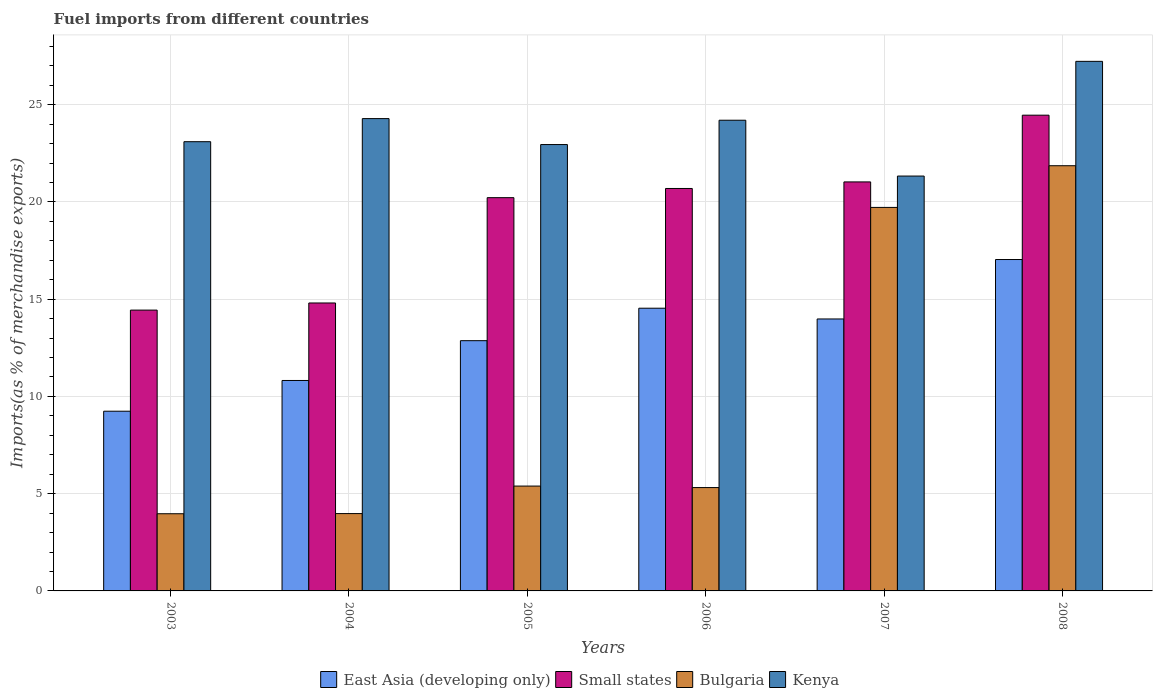How many groups of bars are there?
Your answer should be very brief. 6. What is the label of the 2nd group of bars from the left?
Make the answer very short. 2004. In how many cases, is the number of bars for a given year not equal to the number of legend labels?
Your answer should be very brief. 0. What is the percentage of imports to different countries in Bulgaria in 2006?
Ensure brevity in your answer.  5.31. Across all years, what is the maximum percentage of imports to different countries in East Asia (developing only)?
Offer a very short reply. 17.04. Across all years, what is the minimum percentage of imports to different countries in East Asia (developing only)?
Make the answer very short. 9.24. In which year was the percentage of imports to different countries in Small states maximum?
Your response must be concise. 2008. In which year was the percentage of imports to different countries in Bulgaria minimum?
Ensure brevity in your answer.  2003. What is the total percentage of imports to different countries in East Asia (developing only) in the graph?
Give a very brief answer. 78.48. What is the difference between the percentage of imports to different countries in Bulgaria in 2004 and that in 2008?
Provide a succinct answer. -17.88. What is the difference between the percentage of imports to different countries in Kenya in 2007 and the percentage of imports to different countries in Small states in 2006?
Provide a succinct answer. 0.64. What is the average percentage of imports to different countries in Kenya per year?
Your answer should be compact. 23.85. In the year 2005, what is the difference between the percentage of imports to different countries in Bulgaria and percentage of imports to different countries in Kenya?
Your response must be concise. -17.56. In how many years, is the percentage of imports to different countries in Kenya greater than 27 %?
Offer a terse response. 1. What is the ratio of the percentage of imports to different countries in Kenya in 2003 to that in 2004?
Offer a very short reply. 0.95. Is the percentage of imports to different countries in East Asia (developing only) in 2004 less than that in 2006?
Give a very brief answer. Yes. What is the difference between the highest and the second highest percentage of imports to different countries in East Asia (developing only)?
Make the answer very short. 2.5. What is the difference between the highest and the lowest percentage of imports to different countries in Kenya?
Offer a terse response. 5.9. Is the sum of the percentage of imports to different countries in East Asia (developing only) in 2006 and 2008 greater than the maximum percentage of imports to different countries in Bulgaria across all years?
Make the answer very short. Yes. What does the 4th bar from the left in 2006 represents?
Offer a very short reply. Kenya. What does the 3rd bar from the right in 2008 represents?
Offer a terse response. Small states. Is it the case that in every year, the sum of the percentage of imports to different countries in Small states and percentage of imports to different countries in East Asia (developing only) is greater than the percentage of imports to different countries in Bulgaria?
Keep it short and to the point. Yes. How many years are there in the graph?
Your response must be concise. 6. Does the graph contain any zero values?
Provide a short and direct response. No. Does the graph contain grids?
Offer a terse response. Yes. How many legend labels are there?
Offer a terse response. 4. What is the title of the graph?
Your answer should be very brief. Fuel imports from different countries. What is the label or title of the X-axis?
Give a very brief answer. Years. What is the label or title of the Y-axis?
Provide a short and direct response. Imports(as % of merchandise exports). What is the Imports(as % of merchandise exports) in East Asia (developing only) in 2003?
Offer a terse response. 9.24. What is the Imports(as % of merchandise exports) in Small states in 2003?
Ensure brevity in your answer.  14.44. What is the Imports(as % of merchandise exports) of Bulgaria in 2003?
Offer a terse response. 3.97. What is the Imports(as % of merchandise exports) of Kenya in 2003?
Your response must be concise. 23.1. What is the Imports(as % of merchandise exports) in East Asia (developing only) in 2004?
Keep it short and to the point. 10.82. What is the Imports(as % of merchandise exports) of Small states in 2004?
Offer a very short reply. 14.8. What is the Imports(as % of merchandise exports) of Bulgaria in 2004?
Make the answer very short. 3.98. What is the Imports(as % of merchandise exports) in Kenya in 2004?
Your answer should be compact. 24.28. What is the Imports(as % of merchandise exports) of East Asia (developing only) in 2005?
Provide a short and direct response. 12.87. What is the Imports(as % of merchandise exports) of Small states in 2005?
Your answer should be compact. 20.22. What is the Imports(as % of merchandise exports) of Bulgaria in 2005?
Make the answer very short. 5.39. What is the Imports(as % of merchandise exports) of Kenya in 2005?
Provide a succinct answer. 22.95. What is the Imports(as % of merchandise exports) in East Asia (developing only) in 2006?
Make the answer very short. 14.54. What is the Imports(as % of merchandise exports) in Small states in 2006?
Ensure brevity in your answer.  20.69. What is the Imports(as % of merchandise exports) in Bulgaria in 2006?
Make the answer very short. 5.31. What is the Imports(as % of merchandise exports) in Kenya in 2006?
Your answer should be compact. 24.2. What is the Imports(as % of merchandise exports) in East Asia (developing only) in 2007?
Offer a very short reply. 13.98. What is the Imports(as % of merchandise exports) in Small states in 2007?
Ensure brevity in your answer.  21.03. What is the Imports(as % of merchandise exports) of Bulgaria in 2007?
Your answer should be compact. 19.72. What is the Imports(as % of merchandise exports) in Kenya in 2007?
Provide a succinct answer. 21.33. What is the Imports(as % of merchandise exports) in East Asia (developing only) in 2008?
Offer a very short reply. 17.04. What is the Imports(as % of merchandise exports) of Small states in 2008?
Your answer should be compact. 24.46. What is the Imports(as % of merchandise exports) in Bulgaria in 2008?
Ensure brevity in your answer.  21.86. What is the Imports(as % of merchandise exports) of Kenya in 2008?
Offer a very short reply. 27.23. Across all years, what is the maximum Imports(as % of merchandise exports) of East Asia (developing only)?
Your answer should be very brief. 17.04. Across all years, what is the maximum Imports(as % of merchandise exports) of Small states?
Offer a very short reply. 24.46. Across all years, what is the maximum Imports(as % of merchandise exports) in Bulgaria?
Provide a short and direct response. 21.86. Across all years, what is the maximum Imports(as % of merchandise exports) of Kenya?
Offer a very short reply. 27.23. Across all years, what is the minimum Imports(as % of merchandise exports) in East Asia (developing only)?
Offer a very short reply. 9.24. Across all years, what is the minimum Imports(as % of merchandise exports) of Small states?
Keep it short and to the point. 14.44. Across all years, what is the minimum Imports(as % of merchandise exports) of Bulgaria?
Offer a very short reply. 3.97. Across all years, what is the minimum Imports(as % of merchandise exports) of Kenya?
Give a very brief answer. 21.33. What is the total Imports(as % of merchandise exports) in East Asia (developing only) in the graph?
Ensure brevity in your answer.  78.48. What is the total Imports(as % of merchandise exports) of Small states in the graph?
Provide a succinct answer. 115.64. What is the total Imports(as % of merchandise exports) of Bulgaria in the graph?
Give a very brief answer. 60.23. What is the total Imports(as % of merchandise exports) in Kenya in the graph?
Your answer should be very brief. 143.08. What is the difference between the Imports(as % of merchandise exports) in East Asia (developing only) in 2003 and that in 2004?
Keep it short and to the point. -1.58. What is the difference between the Imports(as % of merchandise exports) of Small states in 2003 and that in 2004?
Your answer should be compact. -0.37. What is the difference between the Imports(as % of merchandise exports) of Bulgaria in 2003 and that in 2004?
Keep it short and to the point. -0.01. What is the difference between the Imports(as % of merchandise exports) in Kenya in 2003 and that in 2004?
Provide a short and direct response. -1.19. What is the difference between the Imports(as % of merchandise exports) of East Asia (developing only) in 2003 and that in 2005?
Give a very brief answer. -3.63. What is the difference between the Imports(as % of merchandise exports) in Small states in 2003 and that in 2005?
Ensure brevity in your answer.  -5.78. What is the difference between the Imports(as % of merchandise exports) in Bulgaria in 2003 and that in 2005?
Give a very brief answer. -1.42. What is the difference between the Imports(as % of merchandise exports) in Kenya in 2003 and that in 2005?
Your answer should be compact. 0.15. What is the difference between the Imports(as % of merchandise exports) of East Asia (developing only) in 2003 and that in 2006?
Provide a short and direct response. -5.3. What is the difference between the Imports(as % of merchandise exports) of Small states in 2003 and that in 2006?
Make the answer very short. -6.25. What is the difference between the Imports(as % of merchandise exports) in Bulgaria in 2003 and that in 2006?
Your response must be concise. -1.35. What is the difference between the Imports(as % of merchandise exports) of Kenya in 2003 and that in 2006?
Your response must be concise. -1.1. What is the difference between the Imports(as % of merchandise exports) of East Asia (developing only) in 2003 and that in 2007?
Your answer should be compact. -4.74. What is the difference between the Imports(as % of merchandise exports) of Small states in 2003 and that in 2007?
Provide a succinct answer. -6.59. What is the difference between the Imports(as % of merchandise exports) in Bulgaria in 2003 and that in 2007?
Provide a succinct answer. -15.75. What is the difference between the Imports(as % of merchandise exports) in Kenya in 2003 and that in 2007?
Your answer should be compact. 1.77. What is the difference between the Imports(as % of merchandise exports) in East Asia (developing only) in 2003 and that in 2008?
Give a very brief answer. -7.8. What is the difference between the Imports(as % of merchandise exports) of Small states in 2003 and that in 2008?
Give a very brief answer. -10.02. What is the difference between the Imports(as % of merchandise exports) of Bulgaria in 2003 and that in 2008?
Provide a succinct answer. -17.89. What is the difference between the Imports(as % of merchandise exports) in Kenya in 2003 and that in 2008?
Provide a succinct answer. -4.13. What is the difference between the Imports(as % of merchandise exports) of East Asia (developing only) in 2004 and that in 2005?
Give a very brief answer. -2.05. What is the difference between the Imports(as % of merchandise exports) of Small states in 2004 and that in 2005?
Keep it short and to the point. -5.41. What is the difference between the Imports(as % of merchandise exports) in Bulgaria in 2004 and that in 2005?
Keep it short and to the point. -1.42. What is the difference between the Imports(as % of merchandise exports) in Kenya in 2004 and that in 2005?
Your answer should be compact. 1.33. What is the difference between the Imports(as % of merchandise exports) of East Asia (developing only) in 2004 and that in 2006?
Keep it short and to the point. -3.72. What is the difference between the Imports(as % of merchandise exports) of Small states in 2004 and that in 2006?
Make the answer very short. -5.89. What is the difference between the Imports(as % of merchandise exports) in Bulgaria in 2004 and that in 2006?
Ensure brevity in your answer.  -1.34. What is the difference between the Imports(as % of merchandise exports) of Kenya in 2004 and that in 2006?
Your answer should be compact. 0.08. What is the difference between the Imports(as % of merchandise exports) of East Asia (developing only) in 2004 and that in 2007?
Ensure brevity in your answer.  -3.16. What is the difference between the Imports(as % of merchandise exports) of Small states in 2004 and that in 2007?
Offer a terse response. -6.22. What is the difference between the Imports(as % of merchandise exports) in Bulgaria in 2004 and that in 2007?
Your response must be concise. -15.74. What is the difference between the Imports(as % of merchandise exports) in Kenya in 2004 and that in 2007?
Provide a short and direct response. 2.95. What is the difference between the Imports(as % of merchandise exports) of East Asia (developing only) in 2004 and that in 2008?
Offer a terse response. -6.22. What is the difference between the Imports(as % of merchandise exports) of Small states in 2004 and that in 2008?
Your response must be concise. -9.65. What is the difference between the Imports(as % of merchandise exports) of Bulgaria in 2004 and that in 2008?
Give a very brief answer. -17.88. What is the difference between the Imports(as % of merchandise exports) in Kenya in 2004 and that in 2008?
Your answer should be very brief. -2.94. What is the difference between the Imports(as % of merchandise exports) in East Asia (developing only) in 2005 and that in 2006?
Your answer should be compact. -1.67. What is the difference between the Imports(as % of merchandise exports) of Small states in 2005 and that in 2006?
Offer a terse response. -0.47. What is the difference between the Imports(as % of merchandise exports) in Bulgaria in 2005 and that in 2006?
Your answer should be very brief. 0.08. What is the difference between the Imports(as % of merchandise exports) in Kenya in 2005 and that in 2006?
Provide a succinct answer. -1.25. What is the difference between the Imports(as % of merchandise exports) in East Asia (developing only) in 2005 and that in 2007?
Provide a succinct answer. -1.12. What is the difference between the Imports(as % of merchandise exports) of Small states in 2005 and that in 2007?
Make the answer very short. -0.81. What is the difference between the Imports(as % of merchandise exports) of Bulgaria in 2005 and that in 2007?
Provide a short and direct response. -14.33. What is the difference between the Imports(as % of merchandise exports) of Kenya in 2005 and that in 2007?
Offer a terse response. 1.62. What is the difference between the Imports(as % of merchandise exports) of East Asia (developing only) in 2005 and that in 2008?
Offer a very short reply. -4.17. What is the difference between the Imports(as % of merchandise exports) of Small states in 2005 and that in 2008?
Offer a very short reply. -4.24. What is the difference between the Imports(as % of merchandise exports) in Bulgaria in 2005 and that in 2008?
Offer a very short reply. -16.47. What is the difference between the Imports(as % of merchandise exports) in Kenya in 2005 and that in 2008?
Give a very brief answer. -4.28. What is the difference between the Imports(as % of merchandise exports) in East Asia (developing only) in 2006 and that in 2007?
Ensure brevity in your answer.  0.55. What is the difference between the Imports(as % of merchandise exports) in Small states in 2006 and that in 2007?
Your response must be concise. -0.34. What is the difference between the Imports(as % of merchandise exports) of Bulgaria in 2006 and that in 2007?
Offer a very short reply. -14.4. What is the difference between the Imports(as % of merchandise exports) in Kenya in 2006 and that in 2007?
Offer a terse response. 2.87. What is the difference between the Imports(as % of merchandise exports) in East Asia (developing only) in 2006 and that in 2008?
Your answer should be compact. -2.5. What is the difference between the Imports(as % of merchandise exports) in Small states in 2006 and that in 2008?
Your response must be concise. -3.77. What is the difference between the Imports(as % of merchandise exports) of Bulgaria in 2006 and that in 2008?
Your answer should be compact. -16.55. What is the difference between the Imports(as % of merchandise exports) in Kenya in 2006 and that in 2008?
Make the answer very short. -3.03. What is the difference between the Imports(as % of merchandise exports) in East Asia (developing only) in 2007 and that in 2008?
Give a very brief answer. -3.06. What is the difference between the Imports(as % of merchandise exports) in Small states in 2007 and that in 2008?
Your answer should be compact. -3.43. What is the difference between the Imports(as % of merchandise exports) in Bulgaria in 2007 and that in 2008?
Keep it short and to the point. -2.14. What is the difference between the Imports(as % of merchandise exports) of Kenya in 2007 and that in 2008?
Keep it short and to the point. -5.9. What is the difference between the Imports(as % of merchandise exports) in East Asia (developing only) in 2003 and the Imports(as % of merchandise exports) in Small states in 2004?
Your answer should be very brief. -5.56. What is the difference between the Imports(as % of merchandise exports) in East Asia (developing only) in 2003 and the Imports(as % of merchandise exports) in Bulgaria in 2004?
Provide a short and direct response. 5.26. What is the difference between the Imports(as % of merchandise exports) of East Asia (developing only) in 2003 and the Imports(as % of merchandise exports) of Kenya in 2004?
Your answer should be compact. -15.04. What is the difference between the Imports(as % of merchandise exports) in Small states in 2003 and the Imports(as % of merchandise exports) in Bulgaria in 2004?
Provide a succinct answer. 10.46. What is the difference between the Imports(as % of merchandise exports) of Small states in 2003 and the Imports(as % of merchandise exports) of Kenya in 2004?
Give a very brief answer. -9.85. What is the difference between the Imports(as % of merchandise exports) in Bulgaria in 2003 and the Imports(as % of merchandise exports) in Kenya in 2004?
Your answer should be very brief. -20.32. What is the difference between the Imports(as % of merchandise exports) of East Asia (developing only) in 2003 and the Imports(as % of merchandise exports) of Small states in 2005?
Keep it short and to the point. -10.98. What is the difference between the Imports(as % of merchandise exports) in East Asia (developing only) in 2003 and the Imports(as % of merchandise exports) in Bulgaria in 2005?
Keep it short and to the point. 3.85. What is the difference between the Imports(as % of merchandise exports) in East Asia (developing only) in 2003 and the Imports(as % of merchandise exports) in Kenya in 2005?
Make the answer very short. -13.71. What is the difference between the Imports(as % of merchandise exports) in Small states in 2003 and the Imports(as % of merchandise exports) in Bulgaria in 2005?
Your answer should be very brief. 9.05. What is the difference between the Imports(as % of merchandise exports) of Small states in 2003 and the Imports(as % of merchandise exports) of Kenya in 2005?
Your response must be concise. -8.51. What is the difference between the Imports(as % of merchandise exports) of Bulgaria in 2003 and the Imports(as % of merchandise exports) of Kenya in 2005?
Offer a terse response. -18.98. What is the difference between the Imports(as % of merchandise exports) of East Asia (developing only) in 2003 and the Imports(as % of merchandise exports) of Small states in 2006?
Give a very brief answer. -11.45. What is the difference between the Imports(as % of merchandise exports) of East Asia (developing only) in 2003 and the Imports(as % of merchandise exports) of Bulgaria in 2006?
Keep it short and to the point. 3.93. What is the difference between the Imports(as % of merchandise exports) in East Asia (developing only) in 2003 and the Imports(as % of merchandise exports) in Kenya in 2006?
Make the answer very short. -14.96. What is the difference between the Imports(as % of merchandise exports) of Small states in 2003 and the Imports(as % of merchandise exports) of Bulgaria in 2006?
Make the answer very short. 9.12. What is the difference between the Imports(as % of merchandise exports) of Small states in 2003 and the Imports(as % of merchandise exports) of Kenya in 2006?
Your answer should be compact. -9.76. What is the difference between the Imports(as % of merchandise exports) in Bulgaria in 2003 and the Imports(as % of merchandise exports) in Kenya in 2006?
Your answer should be very brief. -20.23. What is the difference between the Imports(as % of merchandise exports) in East Asia (developing only) in 2003 and the Imports(as % of merchandise exports) in Small states in 2007?
Give a very brief answer. -11.79. What is the difference between the Imports(as % of merchandise exports) in East Asia (developing only) in 2003 and the Imports(as % of merchandise exports) in Bulgaria in 2007?
Make the answer very short. -10.48. What is the difference between the Imports(as % of merchandise exports) in East Asia (developing only) in 2003 and the Imports(as % of merchandise exports) in Kenya in 2007?
Provide a succinct answer. -12.09. What is the difference between the Imports(as % of merchandise exports) of Small states in 2003 and the Imports(as % of merchandise exports) of Bulgaria in 2007?
Keep it short and to the point. -5.28. What is the difference between the Imports(as % of merchandise exports) in Small states in 2003 and the Imports(as % of merchandise exports) in Kenya in 2007?
Your answer should be compact. -6.89. What is the difference between the Imports(as % of merchandise exports) in Bulgaria in 2003 and the Imports(as % of merchandise exports) in Kenya in 2007?
Your response must be concise. -17.36. What is the difference between the Imports(as % of merchandise exports) of East Asia (developing only) in 2003 and the Imports(as % of merchandise exports) of Small states in 2008?
Your answer should be compact. -15.22. What is the difference between the Imports(as % of merchandise exports) of East Asia (developing only) in 2003 and the Imports(as % of merchandise exports) of Bulgaria in 2008?
Ensure brevity in your answer.  -12.62. What is the difference between the Imports(as % of merchandise exports) in East Asia (developing only) in 2003 and the Imports(as % of merchandise exports) in Kenya in 2008?
Keep it short and to the point. -17.99. What is the difference between the Imports(as % of merchandise exports) of Small states in 2003 and the Imports(as % of merchandise exports) of Bulgaria in 2008?
Offer a very short reply. -7.42. What is the difference between the Imports(as % of merchandise exports) in Small states in 2003 and the Imports(as % of merchandise exports) in Kenya in 2008?
Offer a very short reply. -12.79. What is the difference between the Imports(as % of merchandise exports) in Bulgaria in 2003 and the Imports(as % of merchandise exports) in Kenya in 2008?
Provide a succinct answer. -23.26. What is the difference between the Imports(as % of merchandise exports) in East Asia (developing only) in 2004 and the Imports(as % of merchandise exports) in Small states in 2005?
Give a very brief answer. -9.4. What is the difference between the Imports(as % of merchandise exports) of East Asia (developing only) in 2004 and the Imports(as % of merchandise exports) of Bulgaria in 2005?
Keep it short and to the point. 5.43. What is the difference between the Imports(as % of merchandise exports) of East Asia (developing only) in 2004 and the Imports(as % of merchandise exports) of Kenya in 2005?
Offer a very short reply. -12.13. What is the difference between the Imports(as % of merchandise exports) of Small states in 2004 and the Imports(as % of merchandise exports) of Bulgaria in 2005?
Make the answer very short. 9.41. What is the difference between the Imports(as % of merchandise exports) in Small states in 2004 and the Imports(as % of merchandise exports) in Kenya in 2005?
Offer a terse response. -8.14. What is the difference between the Imports(as % of merchandise exports) of Bulgaria in 2004 and the Imports(as % of merchandise exports) of Kenya in 2005?
Provide a succinct answer. -18.97. What is the difference between the Imports(as % of merchandise exports) in East Asia (developing only) in 2004 and the Imports(as % of merchandise exports) in Small states in 2006?
Give a very brief answer. -9.87. What is the difference between the Imports(as % of merchandise exports) in East Asia (developing only) in 2004 and the Imports(as % of merchandise exports) in Bulgaria in 2006?
Ensure brevity in your answer.  5.51. What is the difference between the Imports(as % of merchandise exports) in East Asia (developing only) in 2004 and the Imports(as % of merchandise exports) in Kenya in 2006?
Your answer should be compact. -13.38. What is the difference between the Imports(as % of merchandise exports) of Small states in 2004 and the Imports(as % of merchandise exports) of Bulgaria in 2006?
Keep it short and to the point. 9.49. What is the difference between the Imports(as % of merchandise exports) in Small states in 2004 and the Imports(as % of merchandise exports) in Kenya in 2006?
Give a very brief answer. -9.4. What is the difference between the Imports(as % of merchandise exports) of Bulgaria in 2004 and the Imports(as % of merchandise exports) of Kenya in 2006?
Provide a succinct answer. -20.22. What is the difference between the Imports(as % of merchandise exports) of East Asia (developing only) in 2004 and the Imports(as % of merchandise exports) of Small states in 2007?
Provide a succinct answer. -10.21. What is the difference between the Imports(as % of merchandise exports) in East Asia (developing only) in 2004 and the Imports(as % of merchandise exports) in Bulgaria in 2007?
Your answer should be compact. -8.9. What is the difference between the Imports(as % of merchandise exports) of East Asia (developing only) in 2004 and the Imports(as % of merchandise exports) of Kenya in 2007?
Keep it short and to the point. -10.51. What is the difference between the Imports(as % of merchandise exports) of Small states in 2004 and the Imports(as % of merchandise exports) of Bulgaria in 2007?
Your answer should be very brief. -4.91. What is the difference between the Imports(as % of merchandise exports) in Small states in 2004 and the Imports(as % of merchandise exports) in Kenya in 2007?
Your answer should be compact. -6.53. What is the difference between the Imports(as % of merchandise exports) of Bulgaria in 2004 and the Imports(as % of merchandise exports) of Kenya in 2007?
Ensure brevity in your answer.  -17.35. What is the difference between the Imports(as % of merchandise exports) in East Asia (developing only) in 2004 and the Imports(as % of merchandise exports) in Small states in 2008?
Your answer should be very brief. -13.64. What is the difference between the Imports(as % of merchandise exports) in East Asia (developing only) in 2004 and the Imports(as % of merchandise exports) in Bulgaria in 2008?
Provide a succinct answer. -11.04. What is the difference between the Imports(as % of merchandise exports) in East Asia (developing only) in 2004 and the Imports(as % of merchandise exports) in Kenya in 2008?
Provide a succinct answer. -16.41. What is the difference between the Imports(as % of merchandise exports) in Small states in 2004 and the Imports(as % of merchandise exports) in Bulgaria in 2008?
Your answer should be very brief. -7.06. What is the difference between the Imports(as % of merchandise exports) in Small states in 2004 and the Imports(as % of merchandise exports) in Kenya in 2008?
Your answer should be very brief. -12.42. What is the difference between the Imports(as % of merchandise exports) of Bulgaria in 2004 and the Imports(as % of merchandise exports) of Kenya in 2008?
Give a very brief answer. -23.25. What is the difference between the Imports(as % of merchandise exports) in East Asia (developing only) in 2005 and the Imports(as % of merchandise exports) in Small states in 2006?
Ensure brevity in your answer.  -7.82. What is the difference between the Imports(as % of merchandise exports) in East Asia (developing only) in 2005 and the Imports(as % of merchandise exports) in Bulgaria in 2006?
Provide a short and direct response. 7.55. What is the difference between the Imports(as % of merchandise exports) in East Asia (developing only) in 2005 and the Imports(as % of merchandise exports) in Kenya in 2006?
Offer a very short reply. -11.33. What is the difference between the Imports(as % of merchandise exports) in Small states in 2005 and the Imports(as % of merchandise exports) in Bulgaria in 2006?
Give a very brief answer. 14.91. What is the difference between the Imports(as % of merchandise exports) of Small states in 2005 and the Imports(as % of merchandise exports) of Kenya in 2006?
Provide a short and direct response. -3.98. What is the difference between the Imports(as % of merchandise exports) of Bulgaria in 2005 and the Imports(as % of merchandise exports) of Kenya in 2006?
Give a very brief answer. -18.81. What is the difference between the Imports(as % of merchandise exports) of East Asia (developing only) in 2005 and the Imports(as % of merchandise exports) of Small states in 2007?
Provide a short and direct response. -8.16. What is the difference between the Imports(as % of merchandise exports) of East Asia (developing only) in 2005 and the Imports(as % of merchandise exports) of Bulgaria in 2007?
Offer a terse response. -6.85. What is the difference between the Imports(as % of merchandise exports) of East Asia (developing only) in 2005 and the Imports(as % of merchandise exports) of Kenya in 2007?
Provide a short and direct response. -8.46. What is the difference between the Imports(as % of merchandise exports) of Small states in 2005 and the Imports(as % of merchandise exports) of Bulgaria in 2007?
Offer a very short reply. 0.5. What is the difference between the Imports(as % of merchandise exports) of Small states in 2005 and the Imports(as % of merchandise exports) of Kenya in 2007?
Make the answer very short. -1.11. What is the difference between the Imports(as % of merchandise exports) in Bulgaria in 2005 and the Imports(as % of merchandise exports) in Kenya in 2007?
Offer a terse response. -15.94. What is the difference between the Imports(as % of merchandise exports) of East Asia (developing only) in 2005 and the Imports(as % of merchandise exports) of Small states in 2008?
Your answer should be very brief. -11.59. What is the difference between the Imports(as % of merchandise exports) of East Asia (developing only) in 2005 and the Imports(as % of merchandise exports) of Bulgaria in 2008?
Your answer should be very brief. -8.99. What is the difference between the Imports(as % of merchandise exports) of East Asia (developing only) in 2005 and the Imports(as % of merchandise exports) of Kenya in 2008?
Your answer should be very brief. -14.36. What is the difference between the Imports(as % of merchandise exports) in Small states in 2005 and the Imports(as % of merchandise exports) in Bulgaria in 2008?
Ensure brevity in your answer.  -1.64. What is the difference between the Imports(as % of merchandise exports) of Small states in 2005 and the Imports(as % of merchandise exports) of Kenya in 2008?
Provide a succinct answer. -7.01. What is the difference between the Imports(as % of merchandise exports) of Bulgaria in 2005 and the Imports(as % of merchandise exports) of Kenya in 2008?
Provide a short and direct response. -21.84. What is the difference between the Imports(as % of merchandise exports) of East Asia (developing only) in 2006 and the Imports(as % of merchandise exports) of Small states in 2007?
Your response must be concise. -6.49. What is the difference between the Imports(as % of merchandise exports) of East Asia (developing only) in 2006 and the Imports(as % of merchandise exports) of Bulgaria in 2007?
Ensure brevity in your answer.  -5.18. What is the difference between the Imports(as % of merchandise exports) of East Asia (developing only) in 2006 and the Imports(as % of merchandise exports) of Kenya in 2007?
Offer a terse response. -6.79. What is the difference between the Imports(as % of merchandise exports) in Small states in 2006 and the Imports(as % of merchandise exports) in Bulgaria in 2007?
Offer a very short reply. 0.97. What is the difference between the Imports(as % of merchandise exports) in Small states in 2006 and the Imports(as % of merchandise exports) in Kenya in 2007?
Provide a short and direct response. -0.64. What is the difference between the Imports(as % of merchandise exports) of Bulgaria in 2006 and the Imports(as % of merchandise exports) of Kenya in 2007?
Give a very brief answer. -16.02. What is the difference between the Imports(as % of merchandise exports) in East Asia (developing only) in 2006 and the Imports(as % of merchandise exports) in Small states in 2008?
Offer a terse response. -9.92. What is the difference between the Imports(as % of merchandise exports) of East Asia (developing only) in 2006 and the Imports(as % of merchandise exports) of Bulgaria in 2008?
Your answer should be compact. -7.33. What is the difference between the Imports(as % of merchandise exports) in East Asia (developing only) in 2006 and the Imports(as % of merchandise exports) in Kenya in 2008?
Ensure brevity in your answer.  -12.69. What is the difference between the Imports(as % of merchandise exports) in Small states in 2006 and the Imports(as % of merchandise exports) in Bulgaria in 2008?
Make the answer very short. -1.17. What is the difference between the Imports(as % of merchandise exports) in Small states in 2006 and the Imports(as % of merchandise exports) in Kenya in 2008?
Your answer should be compact. -6.54. What is the difference between the Imports(as % of merchandise exports) in Bulgaria in 2006 and the Imports(as % of merchandise exports) in Kenya in 2008?
Give a very brief answer. -21.91. What is the difference between the Imports(as % of merchandise exports) in East Asia (developing only) in 2007 and the Imports(as % of merchandise exports) in Small states in 2008?
Your answer should be compact. -10.48. What is the difference between the Imports(as % of merchandise exports) of East Asia (developing only) in 2007 and the Imports(as % of merchandise exports) of Bulgaria in 2008?
Provide a succinct answer. -7.88. What is the difference between the Imports(as % of merchandise exports) in East Asia (developing only) in 2007 and the Imports(as % of merchandise exports) in Kenya in 2008?
Your response must be concise. -13.24. What is the difference between the Imports(as % of merchandise exports) in Small states in 2007 and the Imports(as % of merchandise exports) in Bulgaria in 2008?
Keep it short and to the point. -0.83. What is the difference between the Imports(as % of merchandise exports) in Small states in 2007 and the Imports(as % of merchandise exports) in Kenya in 2008?
Provide a succinct answer. -6.2. What is the difference between the Imports(as % of merchandise exports) in Bulgaria in 2007 and the Imports(as % of merchandise exports) in Kenya in 2008?
Your response must be concise. -7.51. What is the average Imports(as % of merchandise exports) in East Asia (developing only) per year?
Provide a succinct answer. 13.08. What is the average Imports(as % of merchandise exports) in Small states per year?
Give a very brief answer. 19.27. What is the average Imports(as % of merchandise exports) of Bulgaria per year?
Keep it short and to the point. 10.04. What is the average Imports(as % of merchandise exports) in Kenya per year?
Offer a terse response. 23.85. In the year 2003, what is the difference between the Imports(as % of merchandise exports) in East Asia (developing only) and Imports(as % of merchandise exports) in Small states?
Provide a succinct answer. -5.2. In the year 2003, what is the difference between the Imports(as % of merchandise exports) of East Asia (developing only) and Imports(as % of merchandise exports) of Bulgaria?
Your response must be concise. 5.27. In the year 2003, what is the difference between the Imports(as % of merchandise exports) of East Asia (developing only) and Imports(as % of merchandise exports) of Kenya?
Offer a very short reply. -13.86. In the year 2003, what is the difference between the Imports(as % of merchandise exports) of Small states and Imports(as % of merchandise exports) of Bulgaria?
Provide a succinct answer. 10.47. In the year 2003, what is the difference between the Imports(as % of merchandise exports) in Small states and Imports(as % of merchandise exports) in Kenya?
Offer a very short reply. -8.66. In the year 2003, what is the difference between the Imports(as % of merchandise exports) in Bulgaria and Imports(as % of merchandise exports) in Kenya?
Ensure brevity in your answer.  -19.13. In the year 2004, what is the difference between the Imports(as % of merchandise exports) in East Asia (developing only) and Imports(as % of merchandise exports) in Small states?
Your answer should be very brief. -3.98. In the year 2004, what is the difference between the Imports(as % of merchandise exports) of East Asia (developing only) and Imports(as % of merchandise exports) of Bulgaria?
Keep it short and to the point. 6.84. In the year 2004, what is the difference between the Imports(as % of merchandise exports) of East Asia (developing only) and Imports(as % of merchandise exports) of Kenya?
Your answer should be very brief. -13.46. In the year 2004, what is the difference between the Imports(as % of merchandise exports) of Small states and Imports(as % of merchandise exports) of Bulgaria?
Give a very brief answer. 10.83. In the year 2004, what is the difference between the Imports(as % of merchandise exports) in Small states and Imports(as % of merchandise exports) in Kenya?
Your response must be concise. -9.48. In the year 2004, what is the difference between the Imports(as % of merchandise exports) of Bulgaria and Imports(as % of merchandise exports) of Kenya?
Offer a terse response. -20.31. In the year 2005, what is the difference between the Imports(as % of merchandise exports) of East Asia (developing only) and Imports(as % of merchandise exports) of Small states?
Make the answer very short. -7.35. In the year 2005, what is the difference between the Imports(as % of merchandise exports) in East Asia (developing only) and Imports(as % of merchandise exports) in Bulgaria?
Provide a short and direct response. 7.47. In the year 2005, what is the difference between the Imports(as % of merchandise exports) of East Asia (developing only) and Imports(as % of merchandise exports) of Kenya?
Keep it short and to the point. -10.08. In the year 2005, what is the difference between the Imports(as % of merchandise exports) of Small states and Imports(as % of merchandise exports) of Bulgaria?
Your response must be concise. 14.83. In the year 2005, what is the difference between the Imports(as % of merchandise exports) of Small states and Imports(as % of merchandise exports) of Kenya?
Your answer should be compact. -2.73. In the year 2005, what is the difference between the Imports(as % of merchandise exports) of Bulgaria and Imports(as % of merchandise exports) of Kenya?
Offer a very short reply. -17.56. In the year 2006, what is the difference between the Imports(as % of merchandise exports) of East Asia (developing only) and Imports(as % of merchandise exports) of Small states?
Make the answer very short. -6.16. In the year 2006, what is the difference between the Imports(as % of merchandise exports) in East Asia (developing only) and Imports(as % of merchandise exports) in Bulgaria?
Make the answer very short. 9.22. In the year 2006, what is the difference between the Imports(as % of merchandise exports) in East Asia (developing only) and Imports(as % of merchandise exports) in Kenya?
Offer a very short reply. -9.66. In the year 2006, what is the difference between the Imports(as % of merchandise exports) of Small states and Imports(as % of merchandise exports) of Bulgaria?
Your answer should be very brief. 15.38. In the year 2006, what is the difference between the Imports(as % of merchandise exports) of Small states and Imports(as % of merchandise exports) of Kenya?
Make the answer very short. -3.51. In the year 2006, what is the difference between the Imports(as % of merchandise exports) of Bulgaria and Imports(as % of merchandise exports) of Kenya?
Provide a succinct answer. -18.89. In the year 2007, what is the difference between the Imports(as % of merchandise exports) of East Asia (developing only) and Imports(as % of merchandise exports) of Small states?
Your answer should be compact. -7.05. In the year 2007, what is the difference between the Imports(as % of merchandise exports) of East Asia (developing only) and Imports(as % of merchandise exports) of Bulgaria?
Ensure brevity in your answer.  -5.74. In the year 2007, what is the difference between the Imports(as % of merchandise exports) in East Asia (developing only) and Imports(as % of merchandise exports) in Kenya?
Your answer should be compact. -7.35. In the year 2007, what is the difference between the Imports(as % of merchandise exports) in Small states and Imports(as % of merchandise exports) in Bulgaria?
Provide a succinct answer. 1.31. In the year 2007, what is the difference between the Imports(as % of merchandise exports) of Small states and Imports(as % of merchandise exports) of Kenya?
Your response must be concise. -0.3. In the year 2007, what is the difference between the Imports(as % of merchandise exports) in Bulgaria and Imports(as % of merchandise exports) in Kenya?
Offer a terse response. -1.61. In the year 2008, what is the difference between the Imports(as % of merchandise exports) in East Asia (developing only) and Imports(as % of merchandise exports) in Small states?
Your response must be concise. -7.42. In the year 2008, what is the difference between the Imports(as % of merchandise exports) in East Asia (developing only) and Imports(as % of merchandise exports) in Bulgaria?
Ensure brevity in your answer.  -4.82. In the year 2008, what is the difference between the Imports(as % of merchandise exports) in East Asia (developing only) and Imports(as % of merchandise exports) in Kenya?
Make the answer very short. -10.19. In the year 2008, what is the difference between the Imports(as % of merchandise exports) in Small states and Imports(as % of merchandise exports) in Bulgaria?
Make the answer very short. 2.6. In the year 2008, what is the difference between the Imports(as % of merchandise exports) in Small states and Imports(as % of merchandise exports) in Kenya?
Offer a very short reply. -2.77. In the year 2008, what is the difference between the Imports(as % of merchandise exports) of Bulgaria and Imports(as % of merchandise exports) of Kenya?
Offer a terse response. -5.37. What is the ratio of the Imports(as % of merchandise exports) in East Asia (developing only) in 2003 to that in 2004?
Keep it short and to the point. 0.85. What is the ratio of the Imports(as % of merchandise exports) of Small states in 2003 to that in 2004?
Provide a succinct answer. 0.98. What is the ratio of the Imports(as % of merchandise exports) of Kenya in 2003 to that in 2004?
Your response must be concise. 0.95. What is the ratio of the Imports(as % of merchandise exports) of East Asia (developing only) in 2003 to that in 2005?
Make the answer very short. 0.72. What is the ratio of the Imports(as % of merchandise exports) of Small states in 2003 to that in 2005?
Your answer should be very brief. 0.71. What is the ratio of the Imports(as % of merchandise exports) in Bulgaria in 2003 to that in 2005?
Provide a short and direct response. 0.74. What is the ratio of the Imports(as % of merchandise exports) in Kenya in 2003 to that in 2005?
Your answer should be very brief. 1.01. What is the ratio of the Imports(as % of merchandise exports) in East Asia (developing only) in 2003 to that in 2006?
Offer a very short reply. 0.64. What is the ratio of the Imports(as % of merchandise exports) of Small states in 2003 to that in 2006?
Offer a terse response. 0.7. What is the ratio of the Imports(as % of merchandise exports) in Bulgaria in 2003 to that in 2006?
Provide a succinct answer. 0.75. What is the ratio of the Imports(as % of merchandise exports) in Kenya in 2003 to that in 2006?
Offer a very short reply. 0.95. What is the ratio of the Imports(as % of merchandise exports) in East Asia (developing only) in 2003 to that in 2007?
Provide a short and direct response. 0.66. What is the ratio of the Imports(as % of merchandise exports) in Small states in 2003 to that in 2007?
Offer a terse response. 0.69. What is the ratio of the Imports(as % of merchandise exports) of Bulgaria in 2003 to that in 2007?
Your answer should be compact. 0.2. What is the ratio of the Imports(as % of merchandise exports) in Kenya in 2003 to that in 2007?
Your answer should be compact. 1.08. What is the ratio of the Imports(as % of merchandise exports) of East Asia (developing only) in 2003 to that in 2008?
Provide a succinct answer. 0.54. What is the ratio of the Imports(as % of merchandise exports) in Small states in 2003 to that in 2008?
Make the answer very short. 0.59. What is the ratio of the Imports(as % of merchandise exports) in Bulgaria in 2003 to that in 2008?
Provide a succinct answer. 0.18. What is the ratio of the Imports(as % of merchandise exports) of Kenya in 2003 to that in 2008?
Your answer should be compact. 0.85. What is the ratio of the Imports(as % of merchandise exports) of East Asia (developing only) in 2004 to that in 2005?
Your response must be concise. 0.84. What is the ratio of the Imports(as % of merchandise exports) of Small states in 2004 to that in 2005?
Provide a short and direct response. 0.73. What is the ratio of the Imports(as % of merchandise exports) of Bulgaria in 2004 to that in 2005?
Provide a succinct answer. 0.74. What is the ratio of the Imports(as % of merchandise exports) in Kenya in 2004 to that in 2005?
Make the answer very short. 1.06. What is the ratio of the Imports(as % of merchandise exports) of East Asia (developing only) in 2004 to that in 2006?
Keep it short and to the point. 0.74. What is the ratio of the Imports(as % of merchandise exports) in Small states in 2004 to that in 2006?
Keep it short and to the point. 0.72. What is the ratio of the Imports(as % of merchandise exports) of Bulgaria in 2004 to that in 2006?
Your response must be concise. 0.75. What is the ratio of the Imports(as % of merchandise exports) of Kenya in 2004 to that in 2006?
Keep it short and to the point. 1. What is the ratio of the Imports(as % of merchandise exports) in East Asia (developing only) in 2004 to that in 2007?
Give a very brief answer. 0.77. What is the ratio of the Imports(as % of merchandise exports) of Small states in 2004 to that in 2007?
Offer a very short reply. 0.7. What is the ratio of the Imports(as % of merchandise exports) in Bulgaria in 2004 to that in 2007?
Offer a very short reply. 0.2. What is the ratio of the Imports(as % of merchandise exports) of Kenya in 2004 to that in 2007?
Offer a terse response. 1.14. What is the ratio of the Imports(as % of merchandise exports) of East Asia (developing only) in 2004 to that in 2008?
Offer a very short reply. 0.64. What is the ratio of the Imports(as % of merchandise exports) in Small states in 2004 to that in 2008?
Your answer should be very brief. 0.61. What is the ratio of the Imports(as % of merchandise exports) in Bulgaria in 2004 to that in 2008?
Provide a succinct answer. 0.18. What is the ratio of the Imports(as % of merchandise exports) of Kenya in 2004 to that in 2008?
Offer a terse response. 0.89. What is the ratio of the Imports(as % of merchandise exports) in East Asia (developing only) in 2005 to that in 2006?
Ensure brevity in your answer.  0.89. What is the ratio of the Imports(as % of merchandise exports) of Small states in 2005 to that in 2006?
Provide a succinct answer. 0.98. What is the ratio of the Imports(as % of merchandise exports) in Bulgaria in 2005 to that in 2006?
Keep it short and to the point. 1.01. What is the ratio of the Imports(as % of merchandise exports) in Kenya in 2005 to that in 2006?
Give a very brief answer. 0.95. What is the ratio of the Imports(as % of merchandise exports) of East Asia (developing only) in 2005 to that in 2007?
Your response must be concise. 0.92. What is the ratio of the Imports(as % of merchandise exports) of Small states in 2005 to that in 2007?
Offer a terse response. 0.96. What is the ratio of the Imports(as % of merchandise exports) of Bulgaria in 2005 to that in 2007?
Offer a very short reply. 0.27. What is the ratio of the Imports(as % of merchandise exports) of Kenya in 2005 to that in 2007?
Offer a terse response. 1.08. What is the ratio of the Imports(as % of merchandise exports) of East Asia (developing only) in 2005 to that in 2008?
Keep it short and to the point. 0.76. What is the ratio of the Imports(as % of merchandise exports) in Small states in 2005 to that in 2008?
Your response must be concise. 0.83. What is the ratio of the Imports(as % of merchandise exports) in Bulgaria in 2005 to that in 2008?
Your answer should be very brief. 0.25. What is the ratio of the Imports(as % of merchandise exports) of Kenya in 2005 to that in 2008?
Give a very brief answer. 0.84. What is the ratio of the Imports(as % of merchandise exports) in East Asia (developing only) in 2006 to that in 2007?
Keep it short and to the point. 1.04. What is the ratio of the Imports(as % of merchandise exports) of Small states in 2006 to that in 2007?
Make the answer very short. 0.98. What is the ratio of the Imports(as % of merchandise exports) in Bulgaria in 2006 to that in 2007?
Your response must be concise. 0.27. What is the ratio of the Imports(as % of merchandise exports) of Kenya in 2006 to that in 2007?
Keep it short and to the point. 1.13. What is the ratio of the Imports(as % of merchandise exports) of East Asia (developing only) in 2006 to that in 2008?
Give a very brief answer. 0.85. What is the ratio of the Imports(as % of merchandise exports) of Small states in 2006 to that in 2008?
Give a very brief answer. 0.85. What is the ratio of the Imports(as % of merchandise exports) of Bulgaria in 2006 to that in 2008?
Offer a very short reply. 0.24. What is the ratio of the Imports(as % of merchandise exports) in Kenya in 2006 to that in 2008?
Offer a very short reply. 0.89. What is the ratio of the Imports(as % of merchandise exports) of East Asia (developing only) in 2007 to that in 2008?
Keep it short and to the point. 0.82. What is the ratio of the Imports(as % of merchandise exports) in Small states in 2007 to that in 2008?
Your answer should be compact. 0.86. What is the ratio of the Imports(as % of merchandise exports) in Bulgaria in 2007 to that in 2008?
Keep it short and to the point. 0.9. What is the ratio of the Imports(as % of merchandise exports) of Kenya in 2007 to that in 2008?
Offer a terse response. 0.78. What is the difference between the highest and the second highest Imports(as % of merchandise exports) of East Asia (developing only)?
Ensure brevity in your answer.  2.5. What is the difference between the highest and the second highest Imports(as % of merchandise exports) in Small states?
Offer a terse response. 3.43. What is the difference between the highest and the second highest Imports(as % of merchandise exports) of Bulgaria?
Your response must be concise. 2.14. What is the difference between the highest and the second highest Imports(as % of merchandise exports) in Kenya?
Provide a succinct answer. 2.94. What is the difference between the highest and the lowest Imports(as % of merchandise exports) of East Asia (developing only)?
Ensure brevity in your answer.  7.8. What is the difference between the highest and the lowest Imports(as % of merchandise exports) in Small states?
Provide a succinct answer. 10.02. What is the difference between the highest and the lowest Imports(as % of merchandise exports) in Bulgaria?
Your response must be concise. 17.89. What is the difference between the highest and the lowest Imports(as % of merchandise exports) of Kenya?
Your response must be concise. 5.9. 